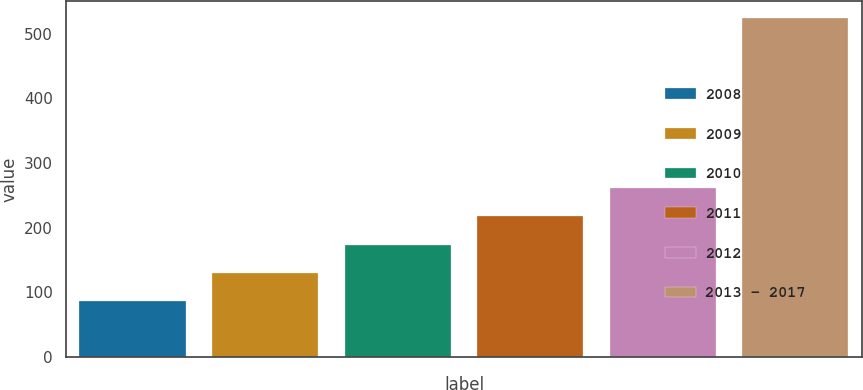<chart> <loc_0><loc_0><loc_500><loc_500><bar_chart><fcel>2008<fcel>2009<fcel>2010<fcel>2011<fcel>2012<fcel>2013 - 2017<nl><fcel>86<fcel>129.8<fcel>173.6<fcel>217.4<fcel>261.2<fcel>524<nl></chart> 